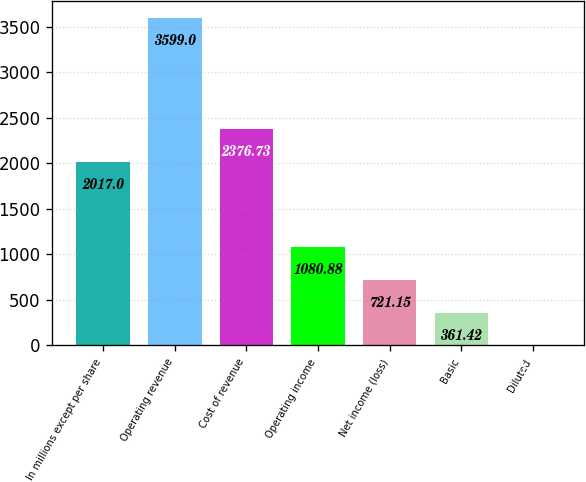Convert chart. <chart><loc_0><loc_0><loc_500><loc_500><bar_chart><fcel>In millions except per share<fcel>Operating revenue<fcel>Cost of revenue<fcel>Operating income<fcel>Net income (loss)<fcel>Basic<fcel>Diluted<nl><fcel>2017<fcel>3599<fcel>2376.73<fcel>1080.88<fcel>721.15<fcel>361.42<fcel>1.69<nl></chart> 